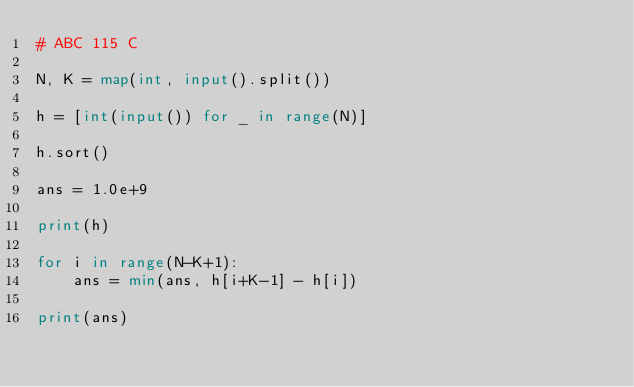Convert code to text. <code><loc_0><loc_0><loc_500><loc_500><_Python_># ABC 115 C

N, K = map(int, input().split())

h = [int(input()) for _ in range(N)]

h.sort()

ans = 1.0e+9

print(h)

for i in range(N-K+1):
    ans = min(ans, h[i+K-1] - h[i])

print(ans)
</code> 